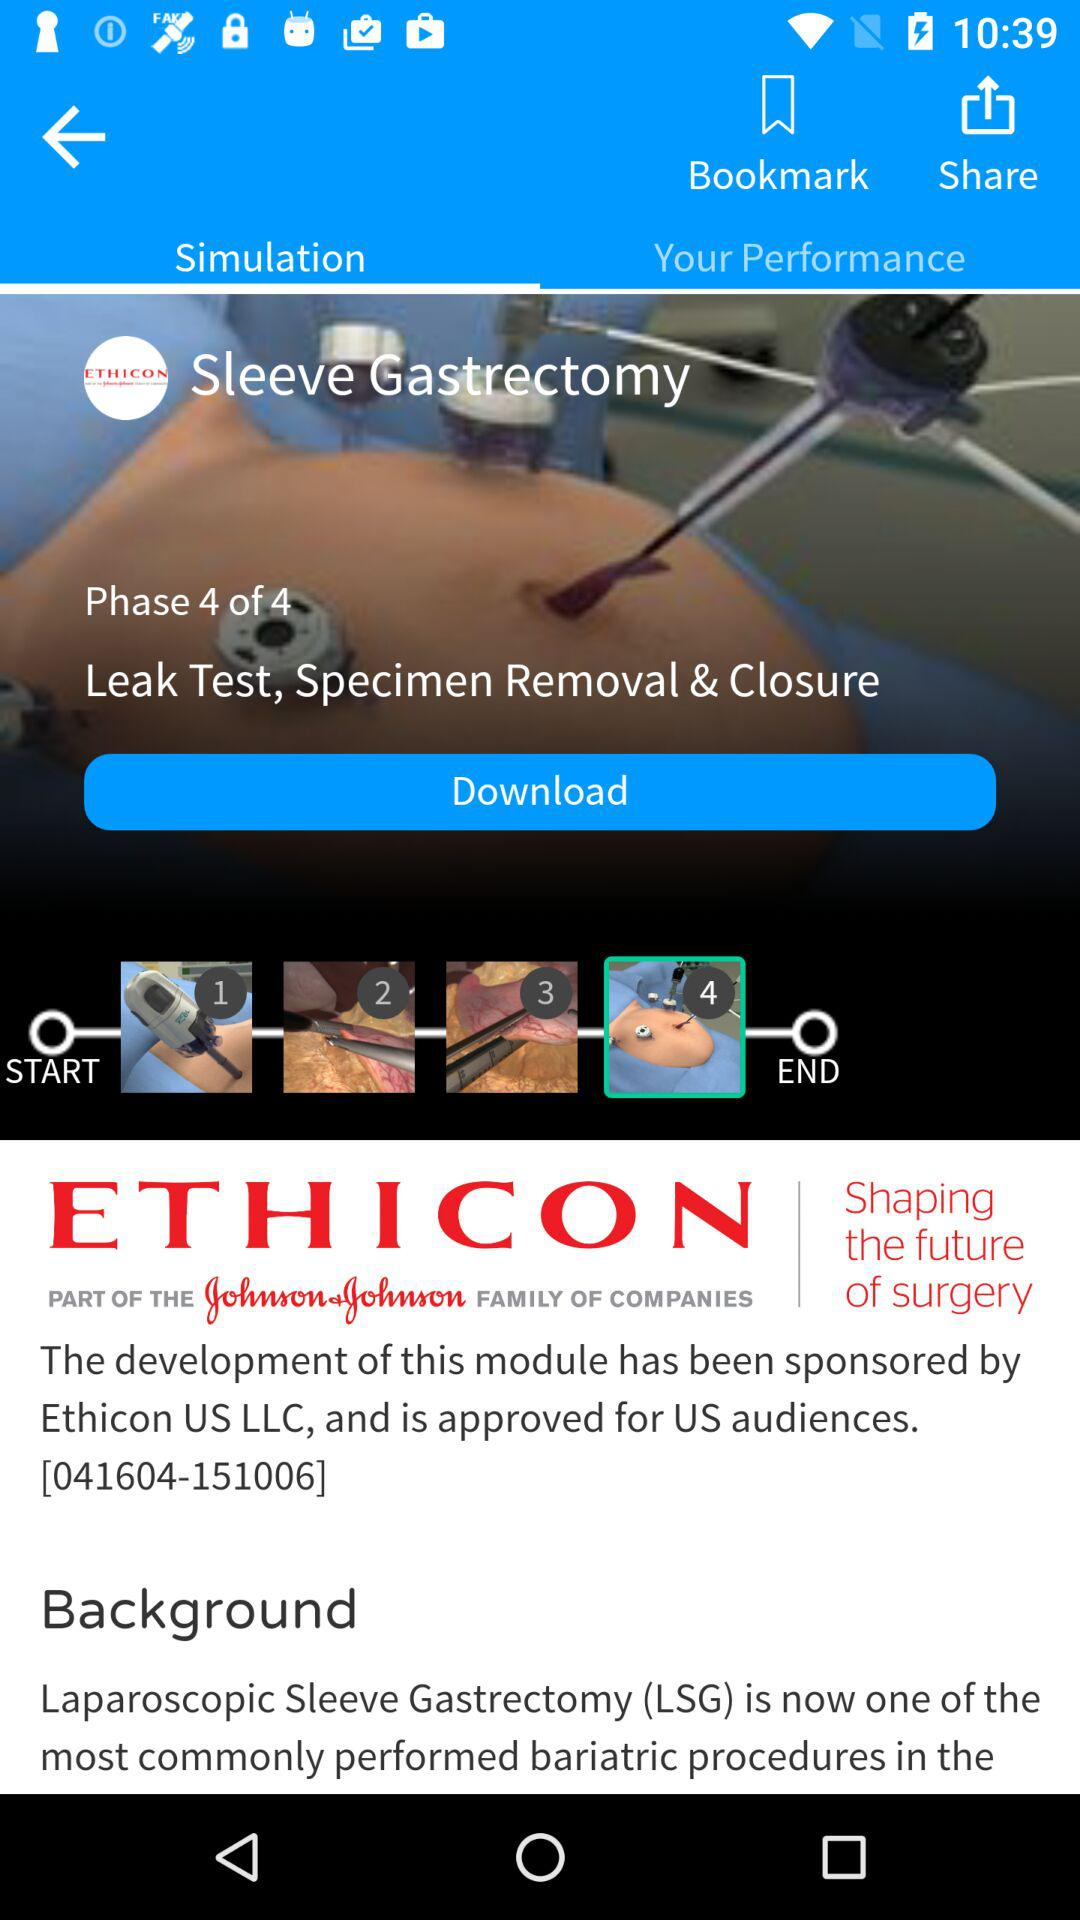How many phases are there? There are 4 phases. 